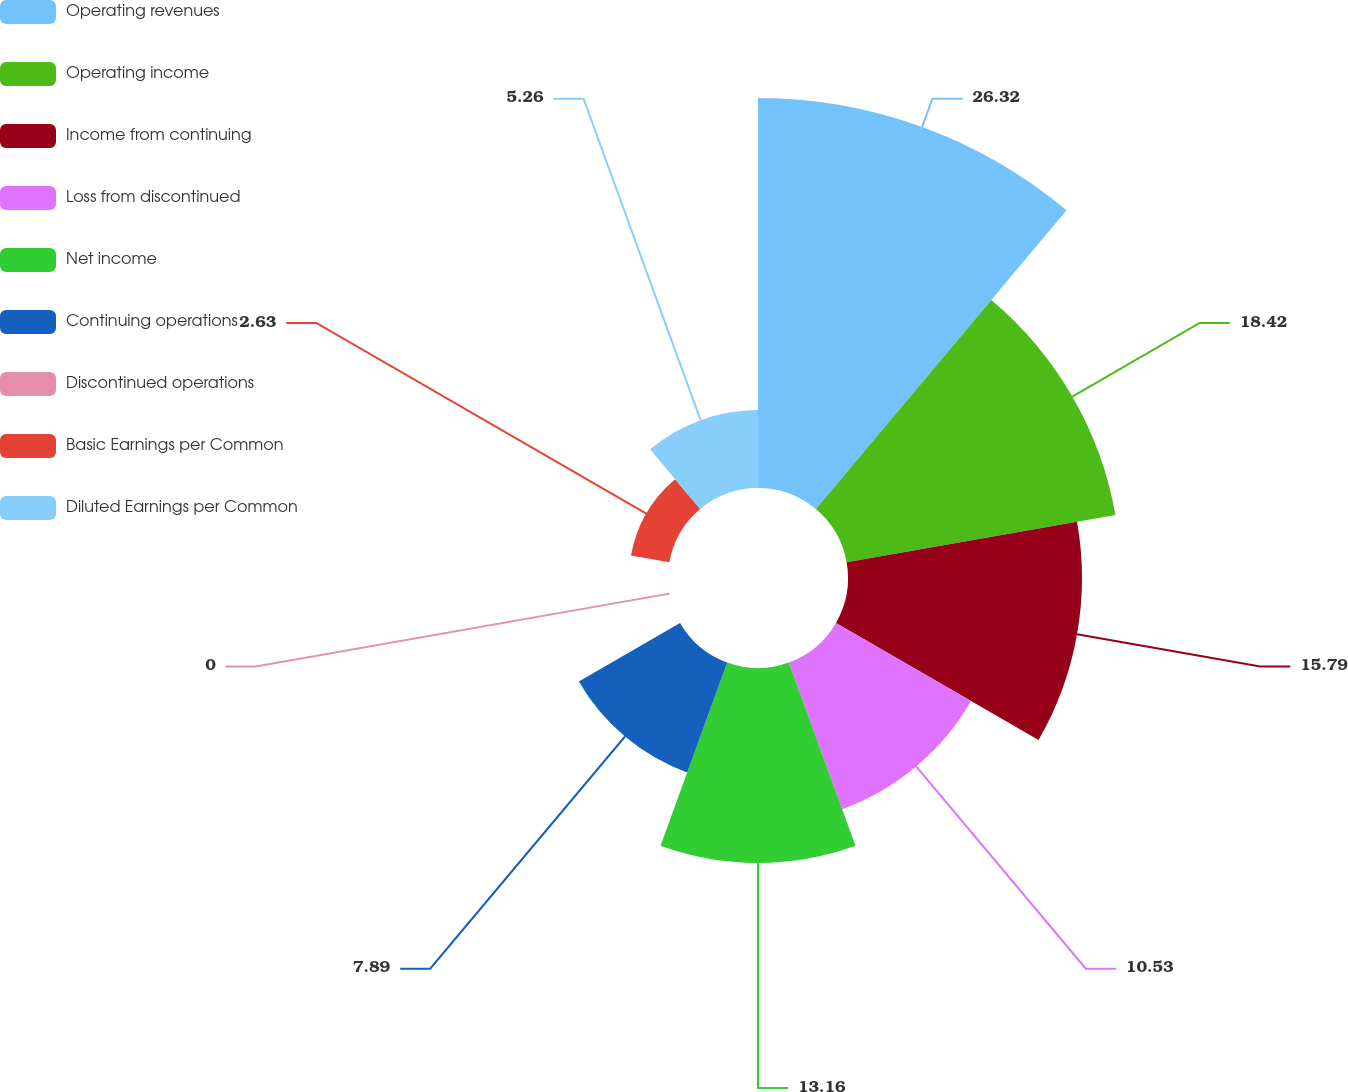Convert chart. <chart><loc_0><loc_0><loc_500><loc_500><pie_chart><fcel>Operating revenues<fcel>Operating income<fcel>Income from continuing<fcel>Loss from discontinued<fcel>Net income<fcel>Continuing operations<fcel>Discontinued operations<fcel>Basic Earnings per Common<fcel>Diluted Earnings per Common<nl><fcel>26.32%<fcel>18.42%<fcel>15.79%<fcel>10.53%<fcel>13.16%<fcel>7.89%<fcel>0.0%<fcel>2.63%<fcel>5.26%<nl></chart> 